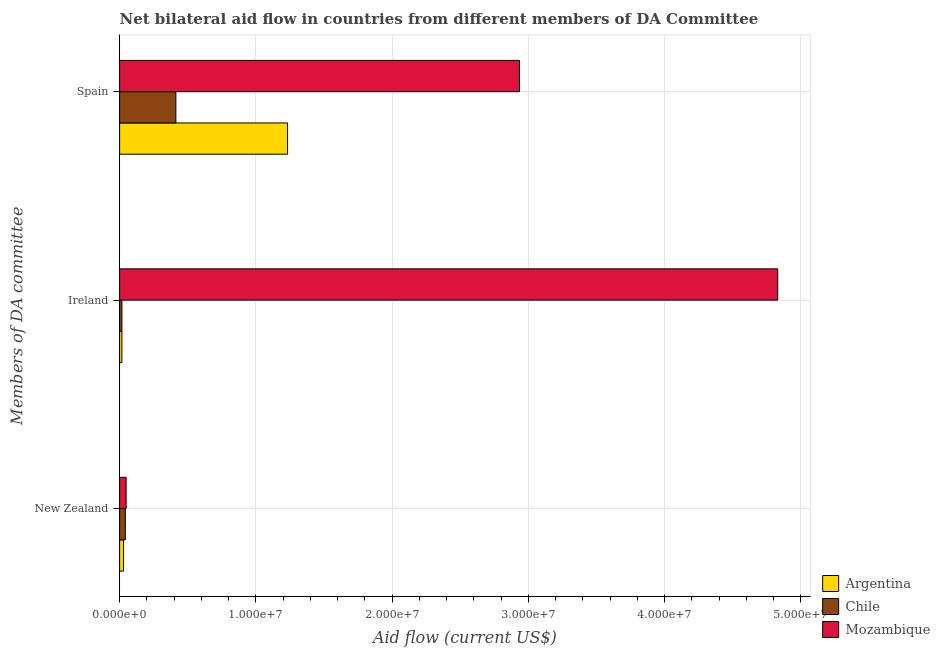Are the number of bars per tick equal to the number of legend labels?
Keep it short and to the point. Yes. How many bars are there on the 3rd tick from the top?
Offer a very short reply. 3. How many bars are there on the 1st tick from the bottom?
Your answer should be very brief. 3. What is the label of the 2nd group of bars from the top?
Keep it short and to the point. Ireland. What is the amount of aid provided by ireland in Mozambique?
Offer a very short reply. 4.83e+07. Across all countries, what is the maximum amount of aid provided by new zealand?
Your answer should be very brief. 4.80e+05. Across all countries, what is the minimum amount of aid provided by spain?
Make the answer very short. 4.13e+06. In which country was the amount of aid provided by new zealand maximum?
Make the answer very short. Mozambique. In which country was the amount of aid provided by spain minimum?
Offer a very short reply. Chile. What is the total amount of aid provided by spain in the graph?
Provide a short and direct response. 4.58e+07. What is the difference between the amount of aid provided by ireland in Chile and that in Mozambique?
Make the answer very short. -4.81e+07. What is the difference between the amount of aid provided by ireland in Chile and the amount of aid provided by spain in Mozambique?
Offer a terse response. -2.92e+07. What is the average amount of aid provided by ireland per country?
Your response must be concise. 1.62e+07. What is the difference between the amount of aid provided by spain and amount of aid provided by new zealand in Argentina?
Ensure brevity in your answer.  1.20e+07. What is the ratio of the amount of aid provided by spain in Mozambique to that in Argentina?
Ensure brevity in your answer.  2.38. Is the amount of aid provided by ireland in Mozambique less than that in Chile?
Provide a succinct answer. No. What is the difference between the highest and the lowest amount of aid provided by new zealand?
Keep it short and to the point. 1.90e+05. In how many countries, is the amount of aid provided by spain greater than the average amount of aid provided by spain taken over all countries?
Offer a terse response. 1. What does the 1st bar from the top in Spain represents?
Ensure brevity in your answer.  Mozambique. How many bars are there?
Your answer should be very brief. 9. Are all the bars in the graph horizontal?
Your answer should be very brief. Yes. How many countries are there in the graph?
Make the answer very short. 3. Are the values on the major ticks of X-axis written in scientific E-notation?
Your answer should be very brief. Yes. Does the graph contain any zero values?
Your answer should be compact. No. How many legend labels are there?
Ensure brevity in your answer.  3. How are the legend labels stacked?
Your answer should be compact. Vertical. What is the title of the graph?
Offer a very short reply. Net bilateral aid flow in countries from different members of DA Committee. Does "Japan" appear as one of the legend labels in the graph?
Provide a short and direct response. No. What is the label or title of the X-axis?
Make the answer very short. Aid flow (current US$). What is the label or title of the Y-axis?
Offer a terse response. Members of DA committee. What is the Aid flow (current US$) of Argentina in New Zealand?
Provide a short and direct response. 2.90e+05. What is the Aid flow (current US$) of Argentina in Ireland?
Offer a very short reply. 1.70e+05. What is the Aid flow (current US$) in Chile in Ireland?
Your answer should be very brief. 1.70e+05. What is the Aid flow (current US$) of Mozambique in Ireland?
Provide a succinct answer. 4.83e+07. What is the Aid flow (current US$) of Argentina in Spain?
Your answer should be very brief. 1.23e+07. What is the Aid flow (current US$) in Chile in Spain?
Offer a terse response. 4.13e+06. What is the Aid flow (current US$) of Mozambique in Spain?
Make the answer very short. 2.94e+07. Across all Members of DA committee, what is the maximum Aid flow (current US$) in Argentina?
Provide a succinct answer. 1.23e+07. Across all Members of DA committee, what is the maximum Aid flow (current US$) in Chile?
Give a very brief answer. 4.13e+06. Across all Members of DA committee, what is the maximum Aid flow (current US$) in Mozambique?
Keep it short and to the point. 4.83e+07. Across all Members of DA committee, what is the minimum Aid flow (current US$) of Argentina?
Provide a succinct answer. 1.70e+05. What is the total Aid flow (current US$) of Argentina in the graph?
Your response must be concise. 1.28e+07. What is the total Aid flow (current US$) in Chile in the graph?
Your answer should be compact. 4.72e+06. What is the total Aid flow (current US$) of Mozambique in the graph?
Keep it short and to the point. 7.81e+07. What is the difference between the Aid flow (current US$) of Chile in New Zealand and that in Ireland?
Offer a terse response. 2.50e+05. What is the difference between the Aid flow (current US$) in Mozambique in New Zealand and that in Ireland?
Keep it short and to the point. -4.78e+07. What is the difference between the Aid flow (current US$) of Argentina in New Zealand and that in Spain?
Offer a terse response. -1.20e+07. What is the difference between the Aid flow (current US$) of Chile in New Zealand and that in Spain?
Your response must be concise. -3.71e+06. What is the difference between the Aid flow (current US$) of Mozambique in New Zealand and that in Spain?
Offer a terse response. -2.89e+07. What is the difference between the Aid flow (current US$) of Argentina in Ireland and that in Spain?
Ensure brevity in your answer.  -1.22e+07. What is the difference between the Aid flow (current US$) in Chile in Ireland and that in Spain?
Your response must be concise. -3.96e+06. What is the difference between the Aid flow (current US$) in Mozambique in Ireland and that in Spain?
Provide a short and direct response. 1.90e+07. What is the difference between the Aid flow (current US$) in Argentina in New Zealand and the Aid flow (current US$) in Mozambique in Ireland?
Your answer should be compact. -4.80e+07. What is the difference between the Aid flow (current US$) in Chile in New Zealand and the Aid flow (current US$) in Mozambique in Ireland?
Keep it short and to the point. -4.79e+07. What is the difference between the Aid flow (current US$) of Argentina in New Zealand and the Aid flow (current US$) of Chile in Spain?
Give a very brief answer. -3.84e+06. What is the difference between the Aid flow (current US$) of Argentina in New Zealand and the Aid flow (current US$) of Mozambique in Spain?
Give a very brief answer. -2.91e+07. What is the difference between the Aid flow (current US$) in Chile in New Zealand and the Aid flow (current US$) in Mozambique in Spain?
Keep it short and to the point. -2.89e+07. What is the difference between the Aid flow (current US$) of Argentina in Ireland and the Aid flow (current US$) of Chile in Spain?
Your response must be concise. -3.96e+06. What is the difference between the Aid flow (current US$) of Argentina in Ireland and the Aid flow (current US$) of Mozambique in Spain?
Your answer should be compact. -2.92e+07. What is the difference between the Aid flow (current US$) in Chile in Ireland and the Aid flow (current US$) in Mozambique in Spain?
Offer a very short reply. -2.92e+07. What is the average Aid flow (current US$) of Argentina per Members of DA committee?
Your answer should be very brief. 4.26e+06. What is the average Aid flow (current US$) of Chile per Members of DA committee?
Your answer should be very brief. 1.57e+06. What is the average Aid flow (current US$) in Mozambique per Members of DA committee?
Ensure brevity in your answer.  2.60e+07. What is the difference between the Aid flow (current US$) in Argentina and Aid flow (current US$) in Chile in New Zealand?
Offer a very short reply. -1.30e+05. What is the difference between the Aid flow (current US$) in Argentina and Aid flow (current US$) in Mozambique in New Zealand?
Ensure brevity in your answer.  -1.90e+05. What is the difference between the Aid flow (current US$) of Argentina and Aid flow (current US$) of Mozambique in Ireland?
Your answer should be compact. -4.81e+07. What is the difference between the Aid flow (current US$) in Chile and Aid flow (current US$) in Mozambique in Ireland?
Ensure brevity in your answer.  -4.81e+07. What is the difference between the Aid flow (current US$) in Argentina and Aid flow (current US$) in Chile in Spain?
Provide a succinct answer. 8.20e+06. What is the difference between the Aid flow (current US$) in Argentina and Aid flow (current US$) in Mozambique in Spain?
Provide a succinct answer. -1.70e+07. What is the difference between the Aid flow (current US$) of Chile and Aid flow (current US$) of Mozambique in Spain?
Your response must be concise. -2.52e+07. What is the ratio of the Aid flow (current US$) of Argentina in New Zealand to that in Ireland?
Make the answer very short. 1.71. What is the ratio of the Aid flow (current US$) of Chile in New Zealand to that in Ireland?
Give a very brief answer. 2.47. What is the ratio of the Aid flow (current US$) of Mozambique in New Zealand to that in Ireland?
Your answer should be very brief. 0.01. What is the ratio of the Aid flow (current US$) of Argentina in New Zealand to that in Spain?
Provide a succinct answer. 0.02. What is the ratio of the Aid flow (current US$) of Chile in New Zealand to that in Spain?
Keep it short and to the point. 0.1. What is the ratio of the Aid flow (current US$) of Mozambique in New Zealand to that in Spain?
Make the answer very short. 0.02. What is the ratio of the Aid flow (current US$) of Argentina in Ireland to that in Spain?
Make the answer very short. 0.01. What is the ratio of the Aid flow (current US$) in Chile in Ireland to that in Spain?
Provide a succinct answer. 0.04. What is the ratio of the Aid flow (current US$) of Mozambique in Ireland to that in Spain?
Offer a terse response. 1.65. What is the difference between the highest and the second highest Aid flow (current US$) of Argentina?
Give a very brief answer. 1.20e+07. What is the difference between the highest and the second highest Aid flow (current US$) of Chile?
Provide a succinct answer. 3.71e+06. What is the difference between the highest and the second highest Aid flow (current US$) of Mozambique?
Your answer should be very brief. 1.90e+07. What is the difference between the highest and the lowest Aid flow (current US$) of Argentina?
Provide a succinct answer. 1.22e+07. What is the difference between the highest and the lowest Aid flow (current US$) in Chile?
Provide a short and direct response. 3.96e+06. What is the difference between the highest and the lowest Aid flow (current US$) in Mozambique?
Ensure brevity in your answer.  4.78e+07. 